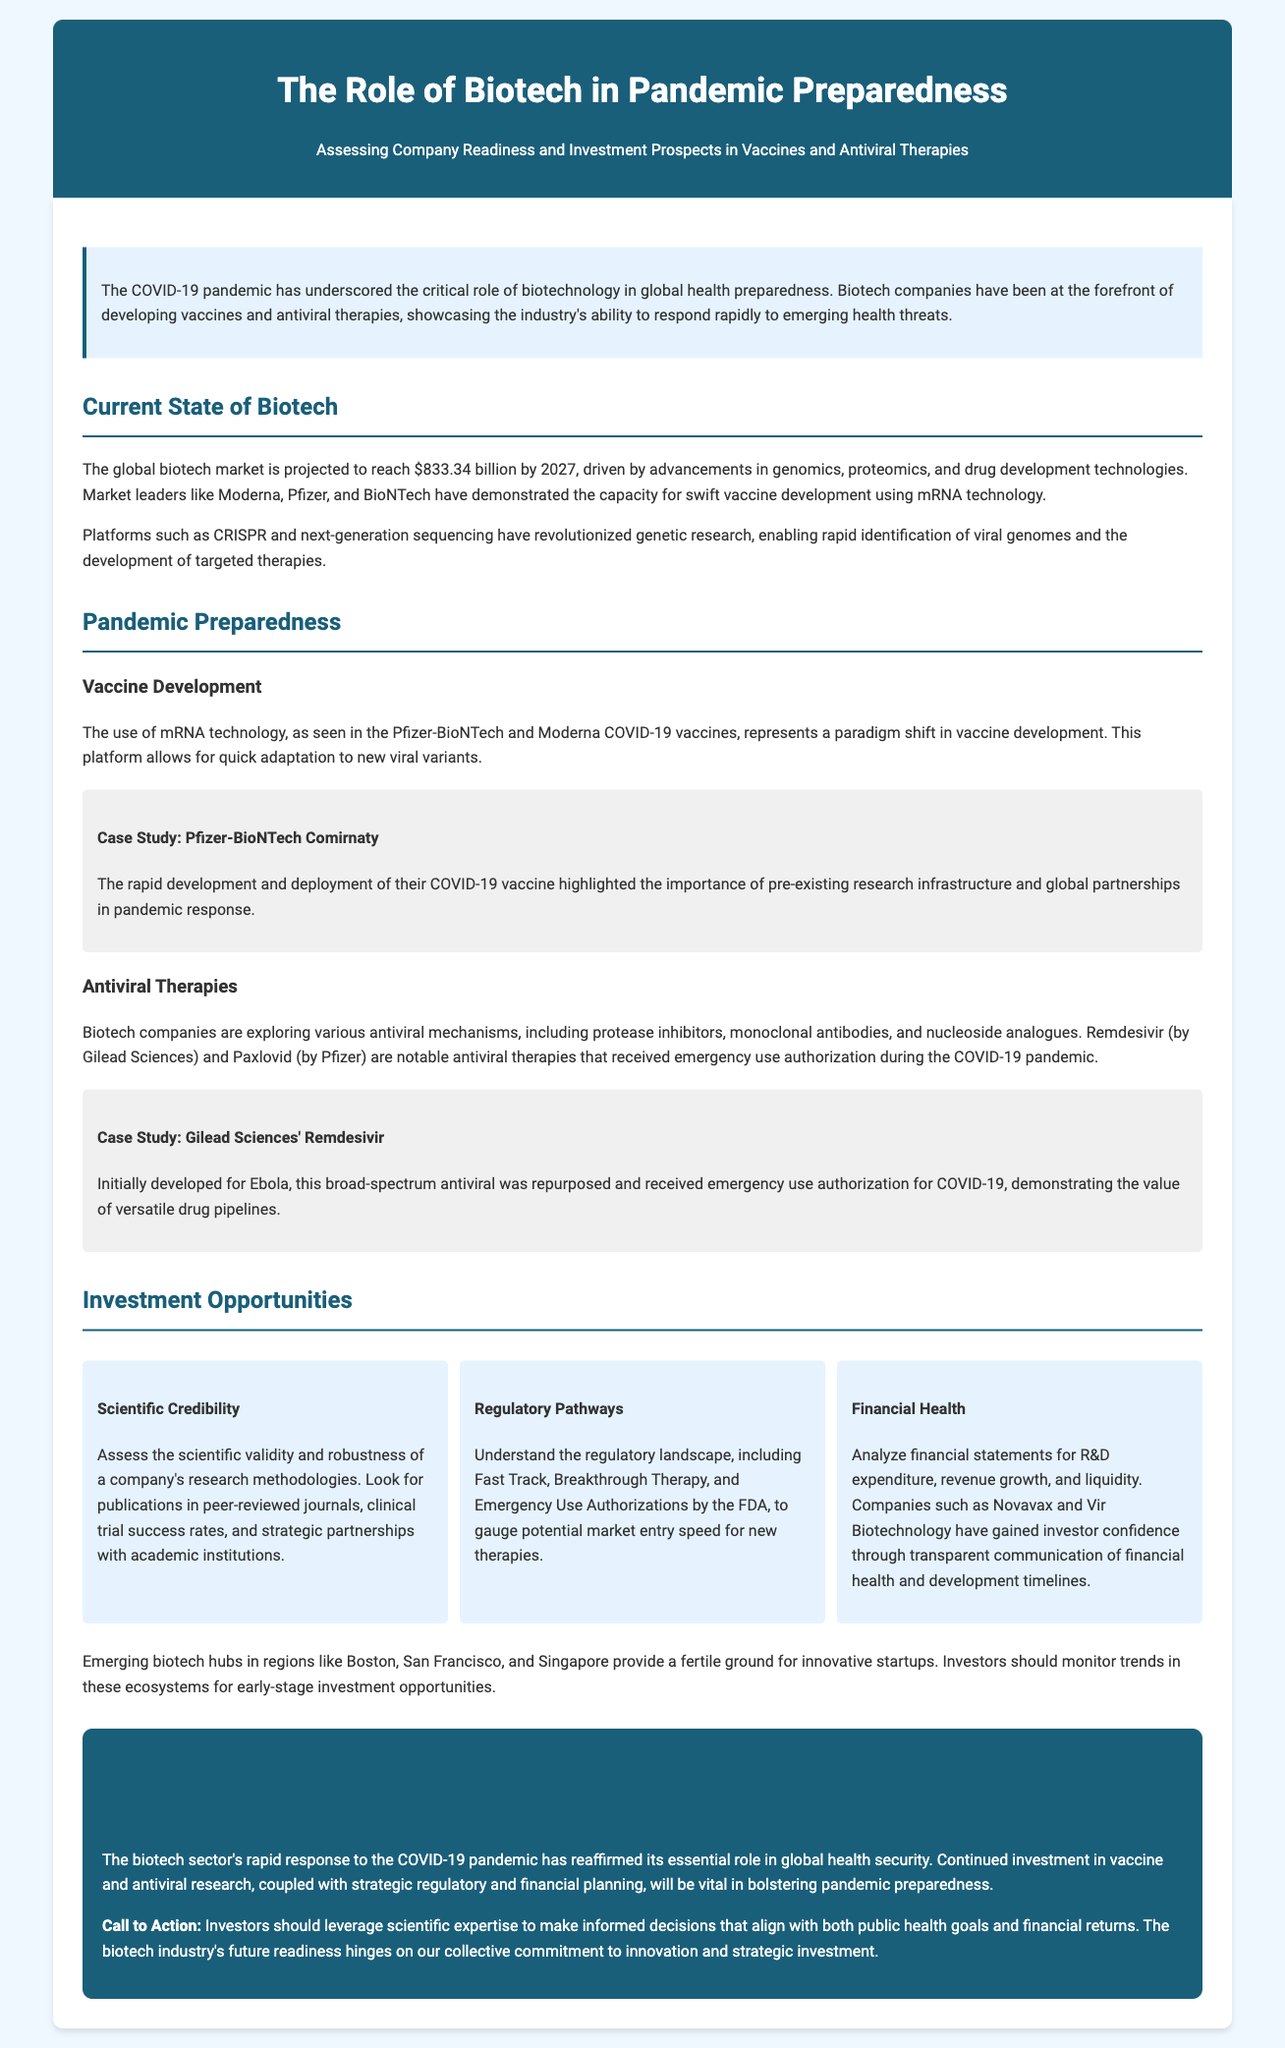What is the projected global biotech market value by 2027? The document states that the global biotech market is projected to reach $833.34 billion by 2027.
Answer: $833.34 billion Which companies demonstrated swift vaccine development using mRNA technology? The document mentions Moderna, Pfizer, and BioNTech as market leaders in swift vaccine development using mRNA technology.
Answer: Moderna, Pfizer, and BioNTech What technology allowed for quick adaptation to new viral variants in vaccine development? The document highlights mRNA technology as the platform that allows for quick adaptation to new viral variants.
Answer: mRNA technology Which antiviral therapy was developed by Gilead Sciences for COVID-19? The document specifies Remdesivir as the antiviral therapy developed by Gilead Sciences for COVID-19.
Answer: Remdesivir What is a key consideration for assessing a company's scientific credibility? The document advises looking for publications in peer-reviewed journals as a key consideration for assessing scientific credibility.
Answer: Publications in peer-reviewed journals How does the document suggest investors assess the regulatory landscape? It mentions understanding Fast Track, Breakthrough Therapy, and Emergency Use Authorizations as ways to assess the regulatory landscape.
Answer: Fast Track, Breakthrough Therapy, and Emergency Use Authorizations What should investors monitor for early-stage investment opportunities in biotech? The document suggests monitoring trends in emerging biotech hubs like Boston, San Francisco, and Singapore for early-stage investment opportunities.
Answer: Trends in Boston, San Francisco, and Singapore What is a significant advantage of the Pfizer-BioNTech COVID-19 vaccine? The document highlights the rapid development and deployment of the vaccine as a significant advantage, illustrating the importance of pre-existing research infrastructure.
Answer: Rapid development and deployment What are two notable antiviral therapies mentioned in the document? The document lists Remdesivir by Gilead Sciences and Paxlovid by Pfizer as two notable antiviral therapies.
Answer: Remdesivir and Paxlovid 